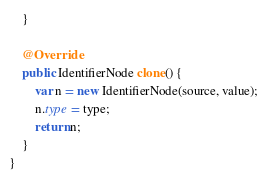Convert code to text. <code><loc_0><loc_0><loc_500><loc_500><_Java_>    }

    @Override
    public IdentifierNode clone() {
        var n = new IdentifierNode(source, value);
        n.type = type;
        return n;
    }
}
</code> 